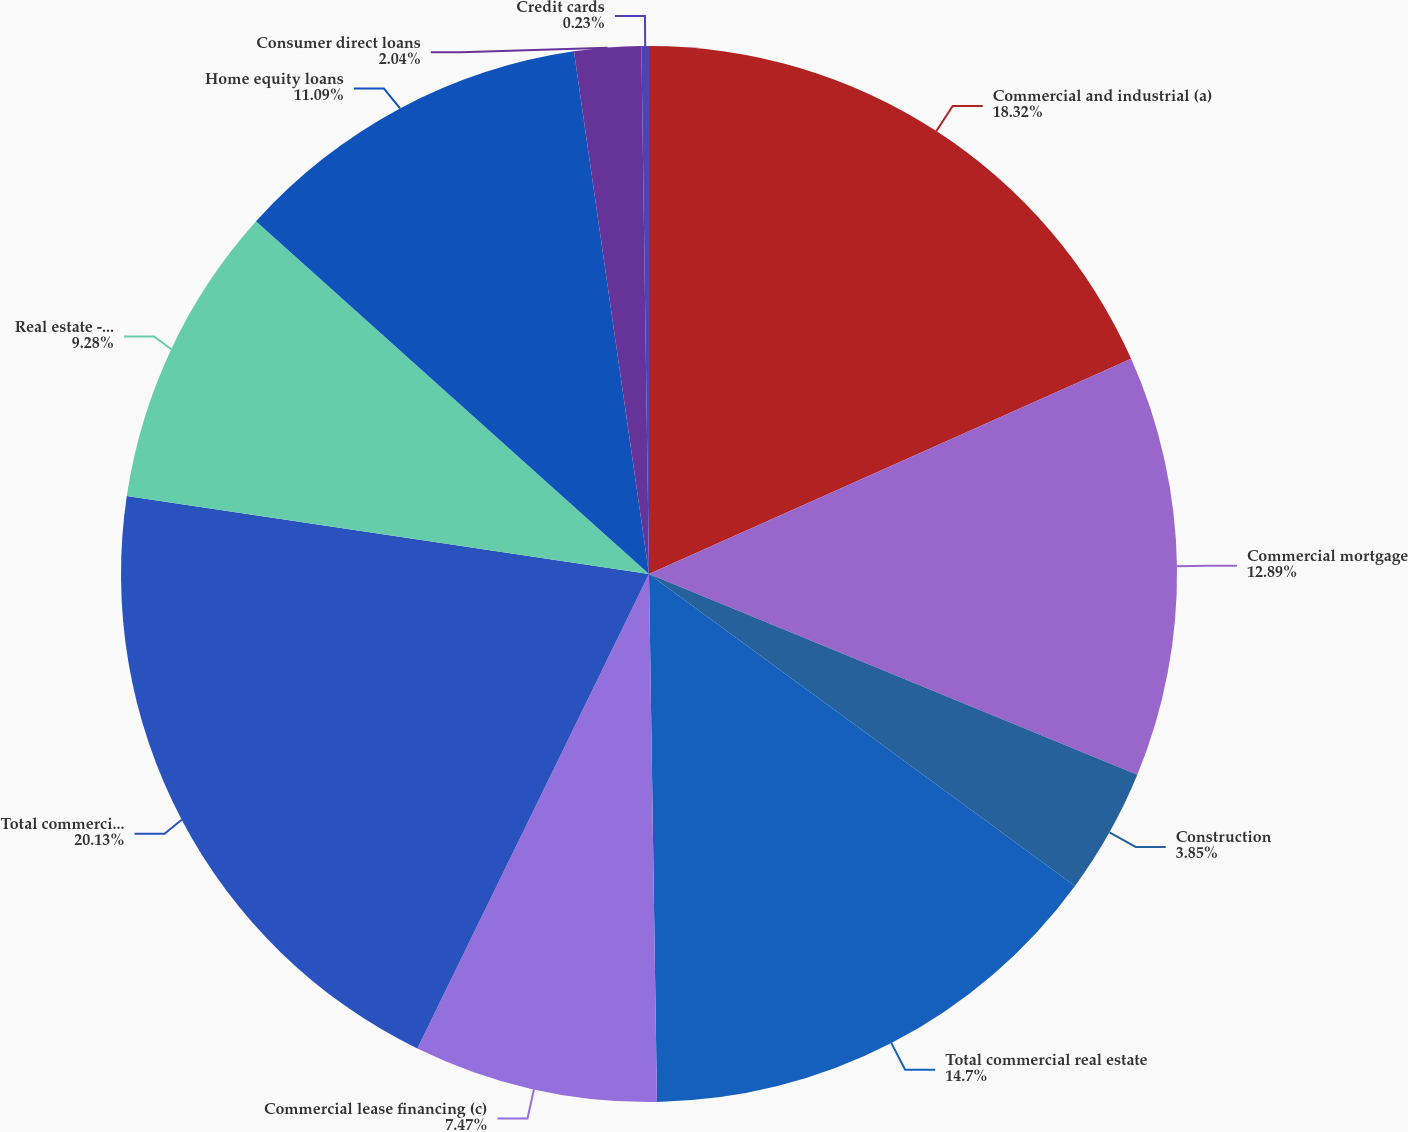Convert chart to OTSL. <chart><loc_0><loc_0><loc_500><loc_500><pie_chart><fcel>Commercial and industrial (a)<fcel>Commercial mortgage<fcel>Construction<fcel>Total commercial real estate<fcel>Commercial lease financing (c)<fcel>Total commercial loans (d)<fcel>Real estate - residential<fcel>Home equity loans<fcel>Consumer direct loans<fcel>Credit cards<nl><fcel>18.32%<fcel>12.89%<fcel>3.85%<fcel>14.7%<fcel>7.47%<fcel>20.13%<fcel>9.28%<fcel>11.09%<fcel>2.04%<fcel>0.23%<nl></chart> 